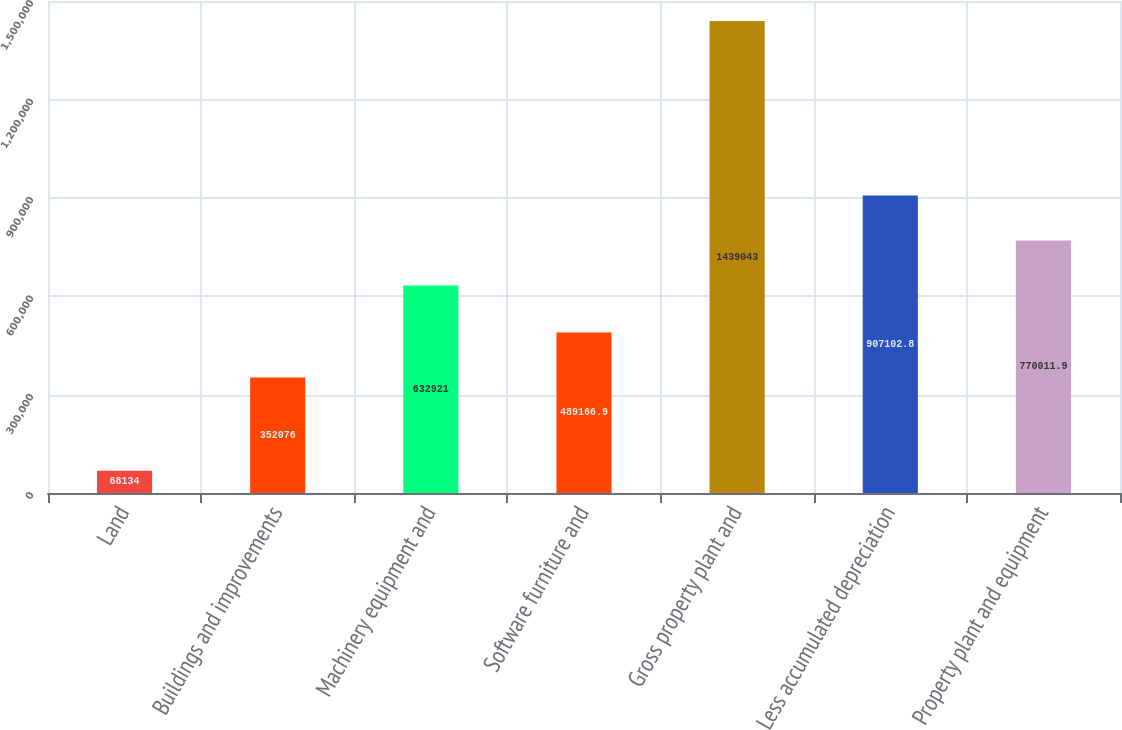Convert chart. <chart><loc_0><loc_0><loc_500><loc_500><bar_chart><fcel>Land<fcel>Buildings and improvements<fcel>Machinery equipment and<fcel>Software furniture and<fcel>Gross property plant and<fcel>Less accumulated depreciation<fcel>Property plant and equipment<nl><fcel>68134<fcel>352076<fcel>632921<fcel>489167<fcel>1.43904e+06<fcel>907103<fcel>770012<nl></chart> 